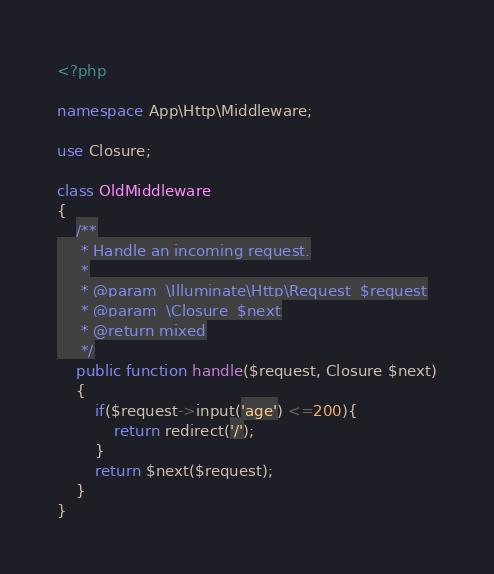Convert code to text. <code><loc_0><loc_0><loc_500><loc_500><_PHP_><?php

namespace App\Http\Middleware;

use Closure;

class OldMiddleware
{
    /**
     * Handle an incoming request.
     *
     * @param  \Illuminate\Http\Request  $request
     * @param  \Closure  $next
     * @return mixed
     */
    public function handle($request, Closure $next)
    {
        if($request->input('age') <=200){
            return redirect('/');
        }
        return $next($request);
    }
}
</code> 